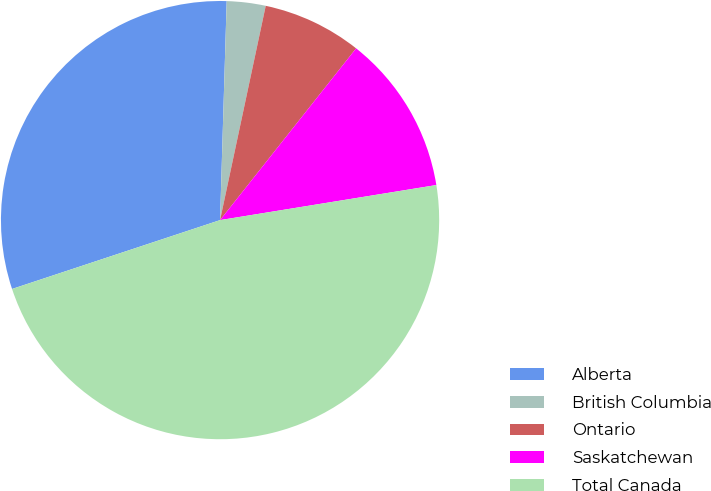Convert chart to OTSL. <chart><loc_0><loc_0><loc_500><loc_500><pie_chart><fcel>Alberta<fcel>British Columbia<fcel>Ontario<fcel>Saskatchewan<fcel>Total Canada<nl><fcel>30.57%<fcel>2.86%<fcel>7.32%<fcel>11.78%<fcel>47.47%<nl></chart> 